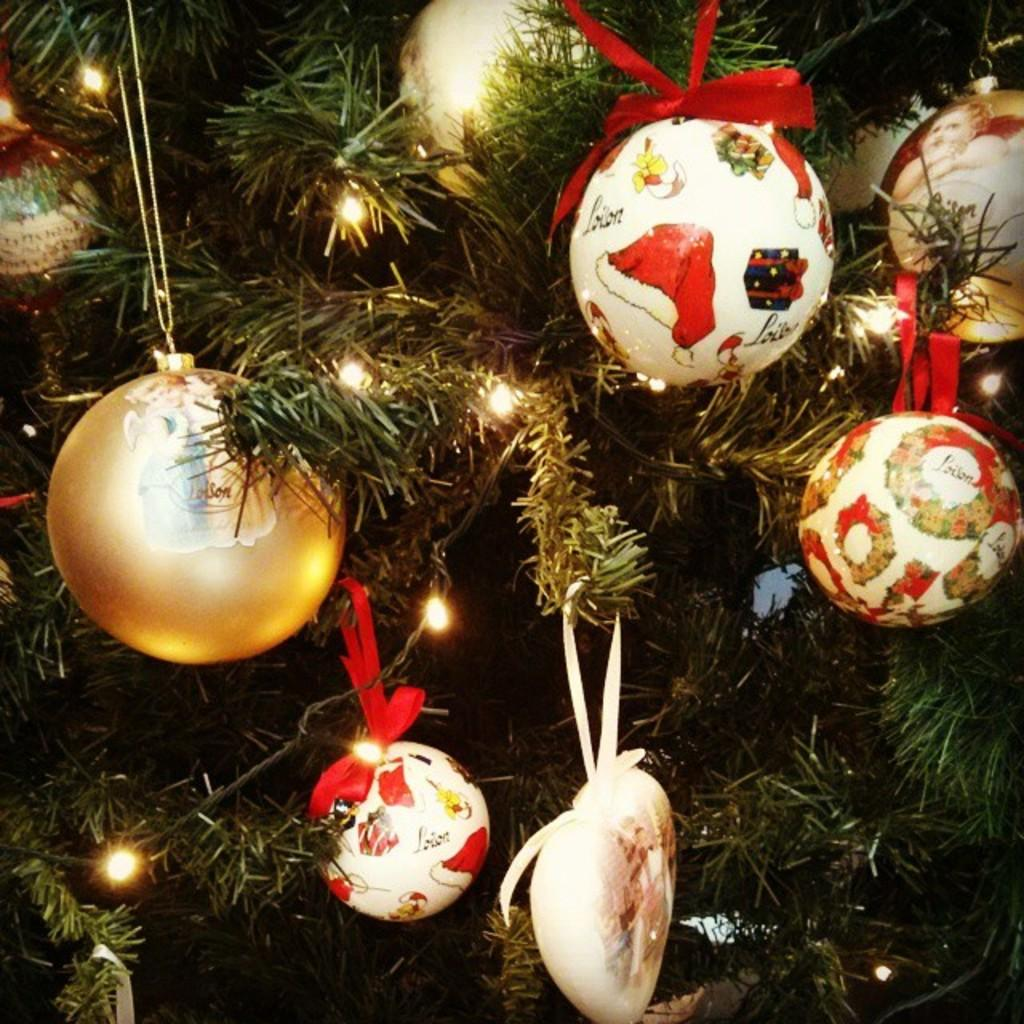What is the main subject of the picture? The main subject of the picture is a Christmas tree. What is unique about this Christmas tree? The Christmas tree is filled with balloons. Are there any other decorations on the tree besides balloons? Yes, there are other objects on the Christmas tree. What type of lighting is used to illuminate the tree? There are lights designed on the tree. Can you see the hands of the person holding the Christmas tree in the image? There is no person holding the Christmas tree in the image, so their hands cannot be seen. 